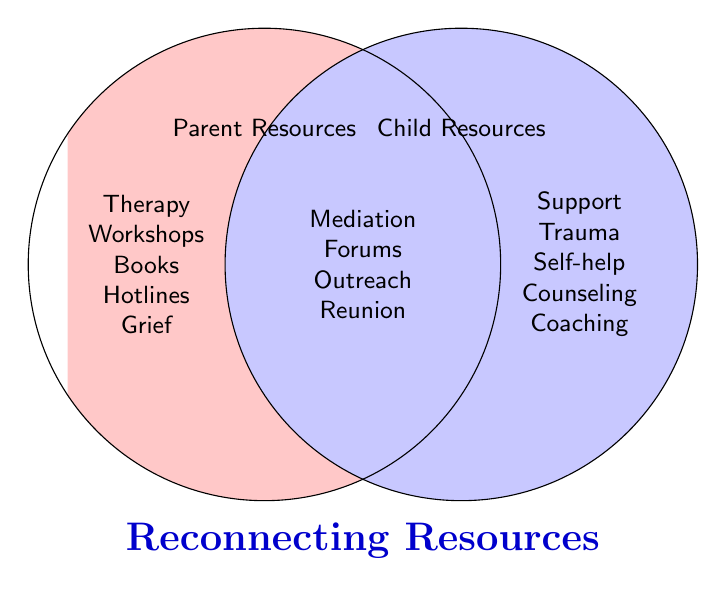What is the title of the Venn Diagram? The title is located below the circles and is usually used to denote the overall subject of the Venn Diagram. In this case, it's "Reconnecting Resources".
Answer: Reconnecting Resources Which resource is only found in the Parent Resources set? By looking at the left circle, which represents Parent Resources, we can see a list including "Therapy Workshops,” “Books,” “Hotlines," and “Grief”. "Therapy Workshops" is listed there.
Answer: Therapy Workshops Compare the number of resources listed uniquely under Parent and Child Resources. Which set has more unique resources? The Parent Resources section lists 5 unique items (Therapy Workshops, Books, Hotlines, Grief), and the Child Resources section also lists 5 unique items (Support, Trauma, Self-help, Counseling, Coaching). Both have the same number.
Answer: Neither, both have 5 What types of services are shared by both parents and children for reconnecting? The shared services are located in the intersection of the two circles, which are: Mediation, Forums, Outreach, and Reunion.
Answer: Mediation, Forums, Outreach, Reunion Imagine wanting initial support to start the reconnection process. Which shared resource might be the best starting point based on the categories listed? Mediation services are commonly used initial steps for beginning reconnection because they directly involve both parties.
Answer: Mediation Which unique resource for Child Resources could help with self-improvement? The unique Child Resources list mentions Life Coaching, which is aimed at personal development and self-improvement.
Answer: Life Coaching Count the total number of distinct resources listed across both sets and the intersection. Add the unique and shared resources: Parent (Therapy Workshops, Books, Hotlines, Grief) + Child (Support, Trauma, Self-help, Counseling, Coaching) + Intersection (Mediation, Forums, Outreach, Reunion). This totals 13 distinct items.
Answer: 13 Which side (Parent or Child) includes Self-help books? According to the lists in the circle, Self-help books are under Child Resources.
Answer: Child How many specific resource categories are shared between Parent and Child? The intersection of the circles shows all shared resource categories, which are Mediation, Forums, Outreach, and Reunion. Thus, there are 4 categories shared.
Answer: 4 If a child prefers online help, which shared resource could they use? Online forums are part of the intersection, which implies they are shared and can be used by both parents and children. It is also conducive to online help.
Answer: Online forums 